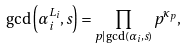<formula> <loc_0><loc_0><loc_500><loc_500>\gcd \left ( \alpha _ { i } ^ { L _ { i } } , s \right ) = \prod _ { p | \gcd ( \alpha _ { i } , s ) } { p ^ { \kappa _ { p } } } ,</formula> 